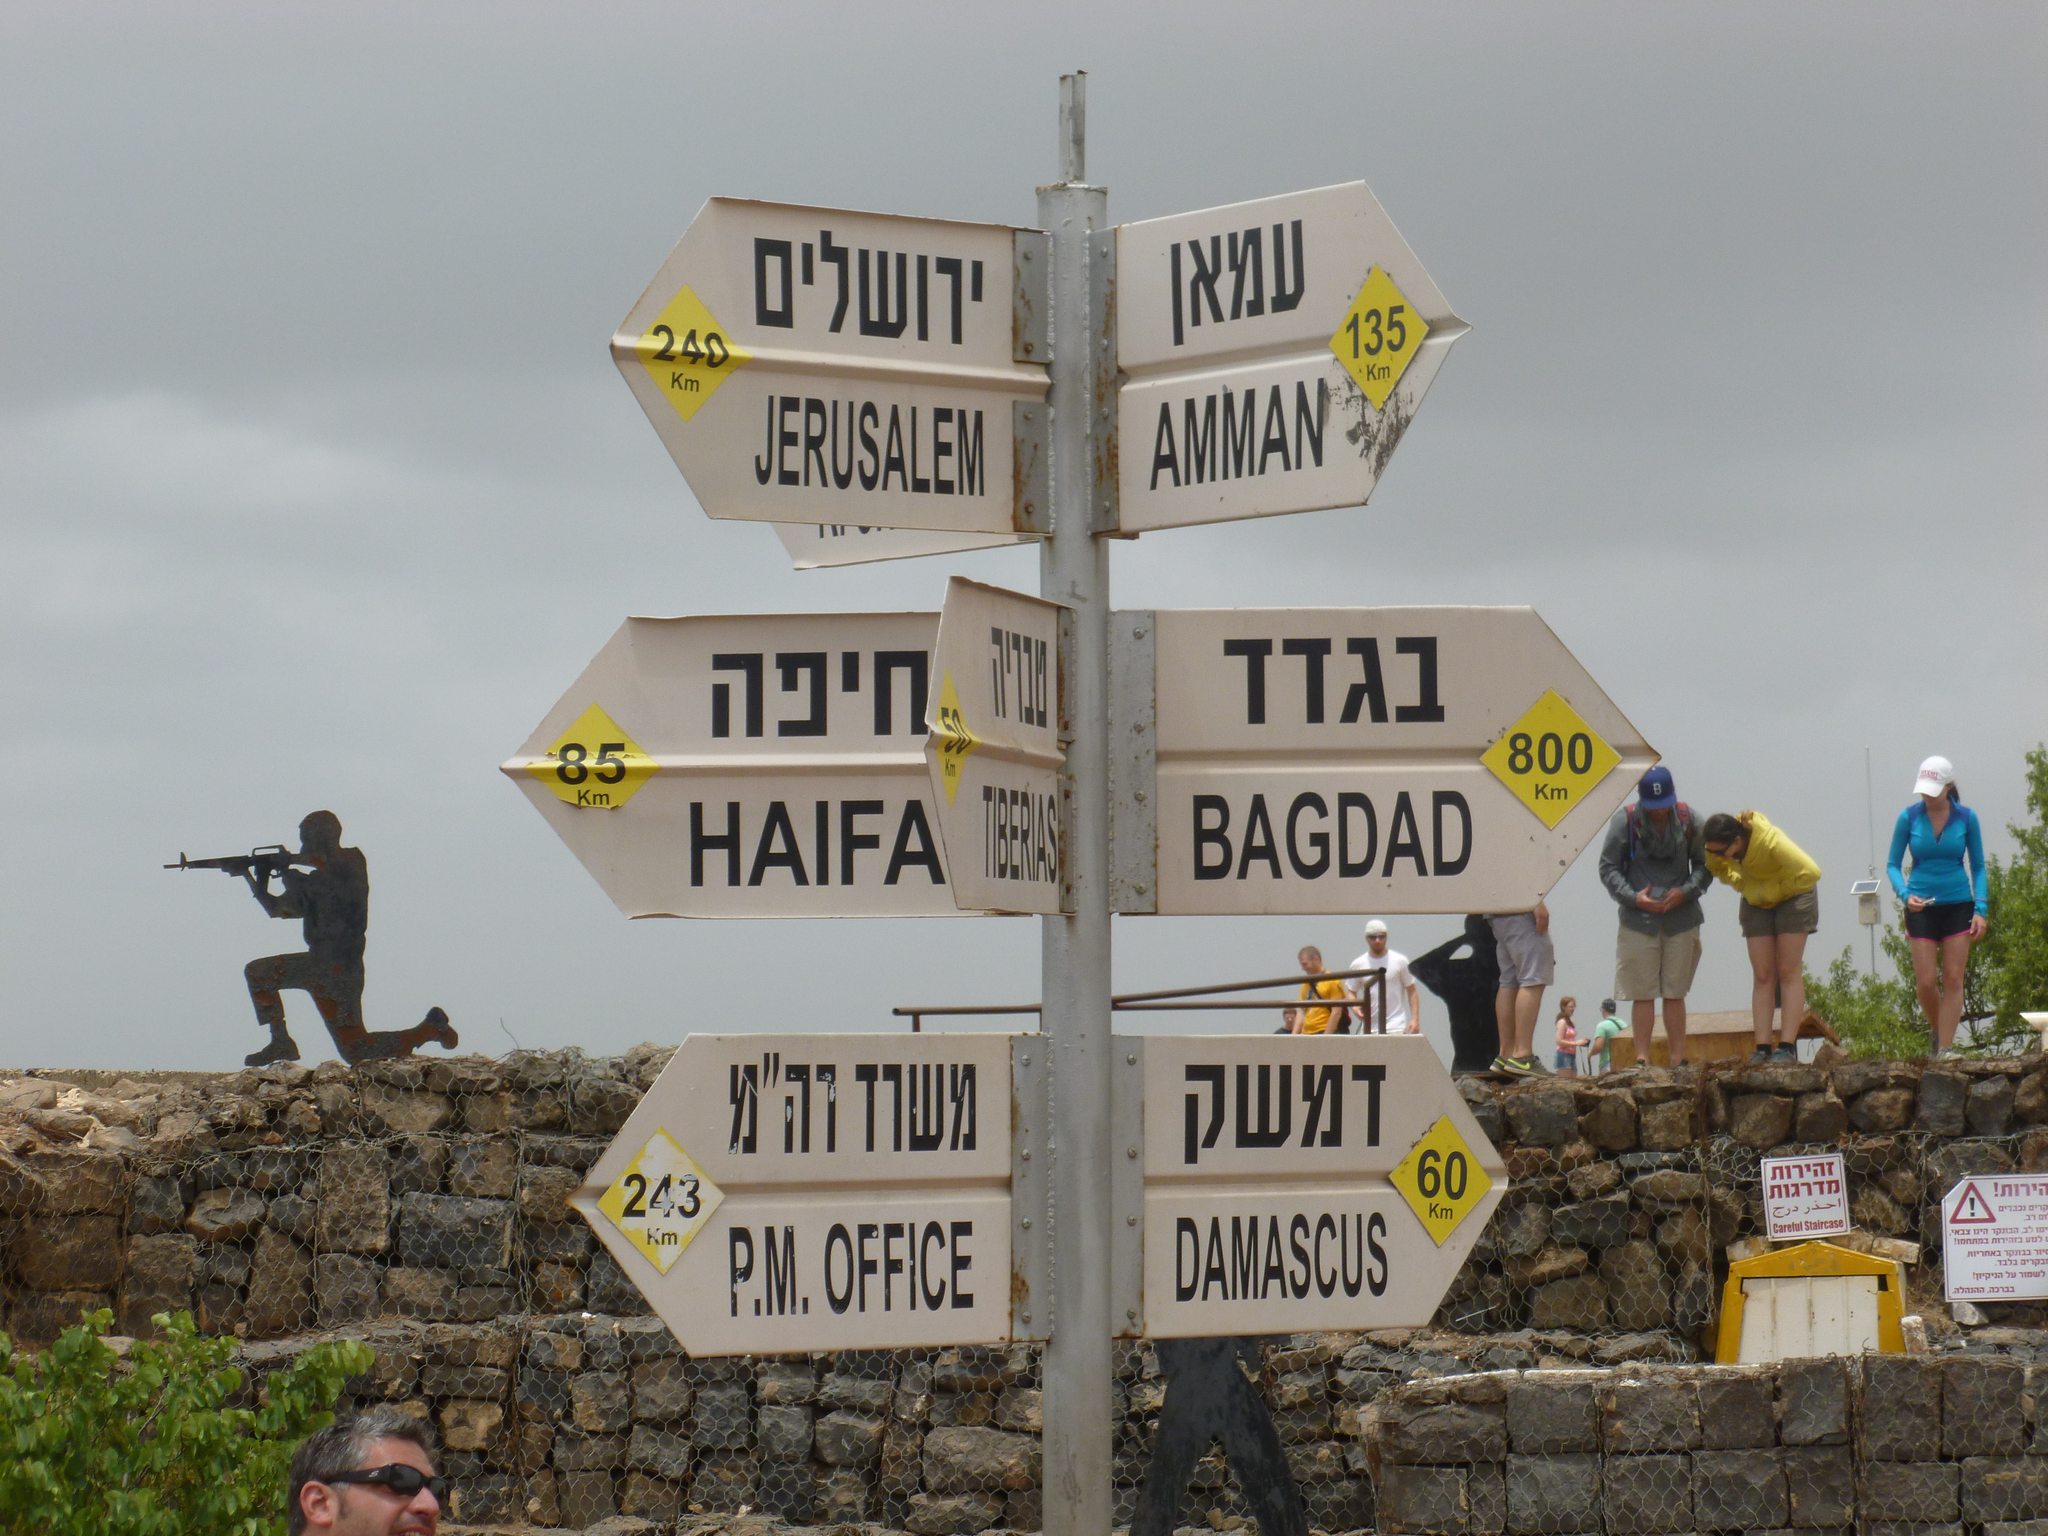How far is damascus?
Give a very brief answer. 60. How far to bagdad?
Your answer should be very brief. 800 km. 